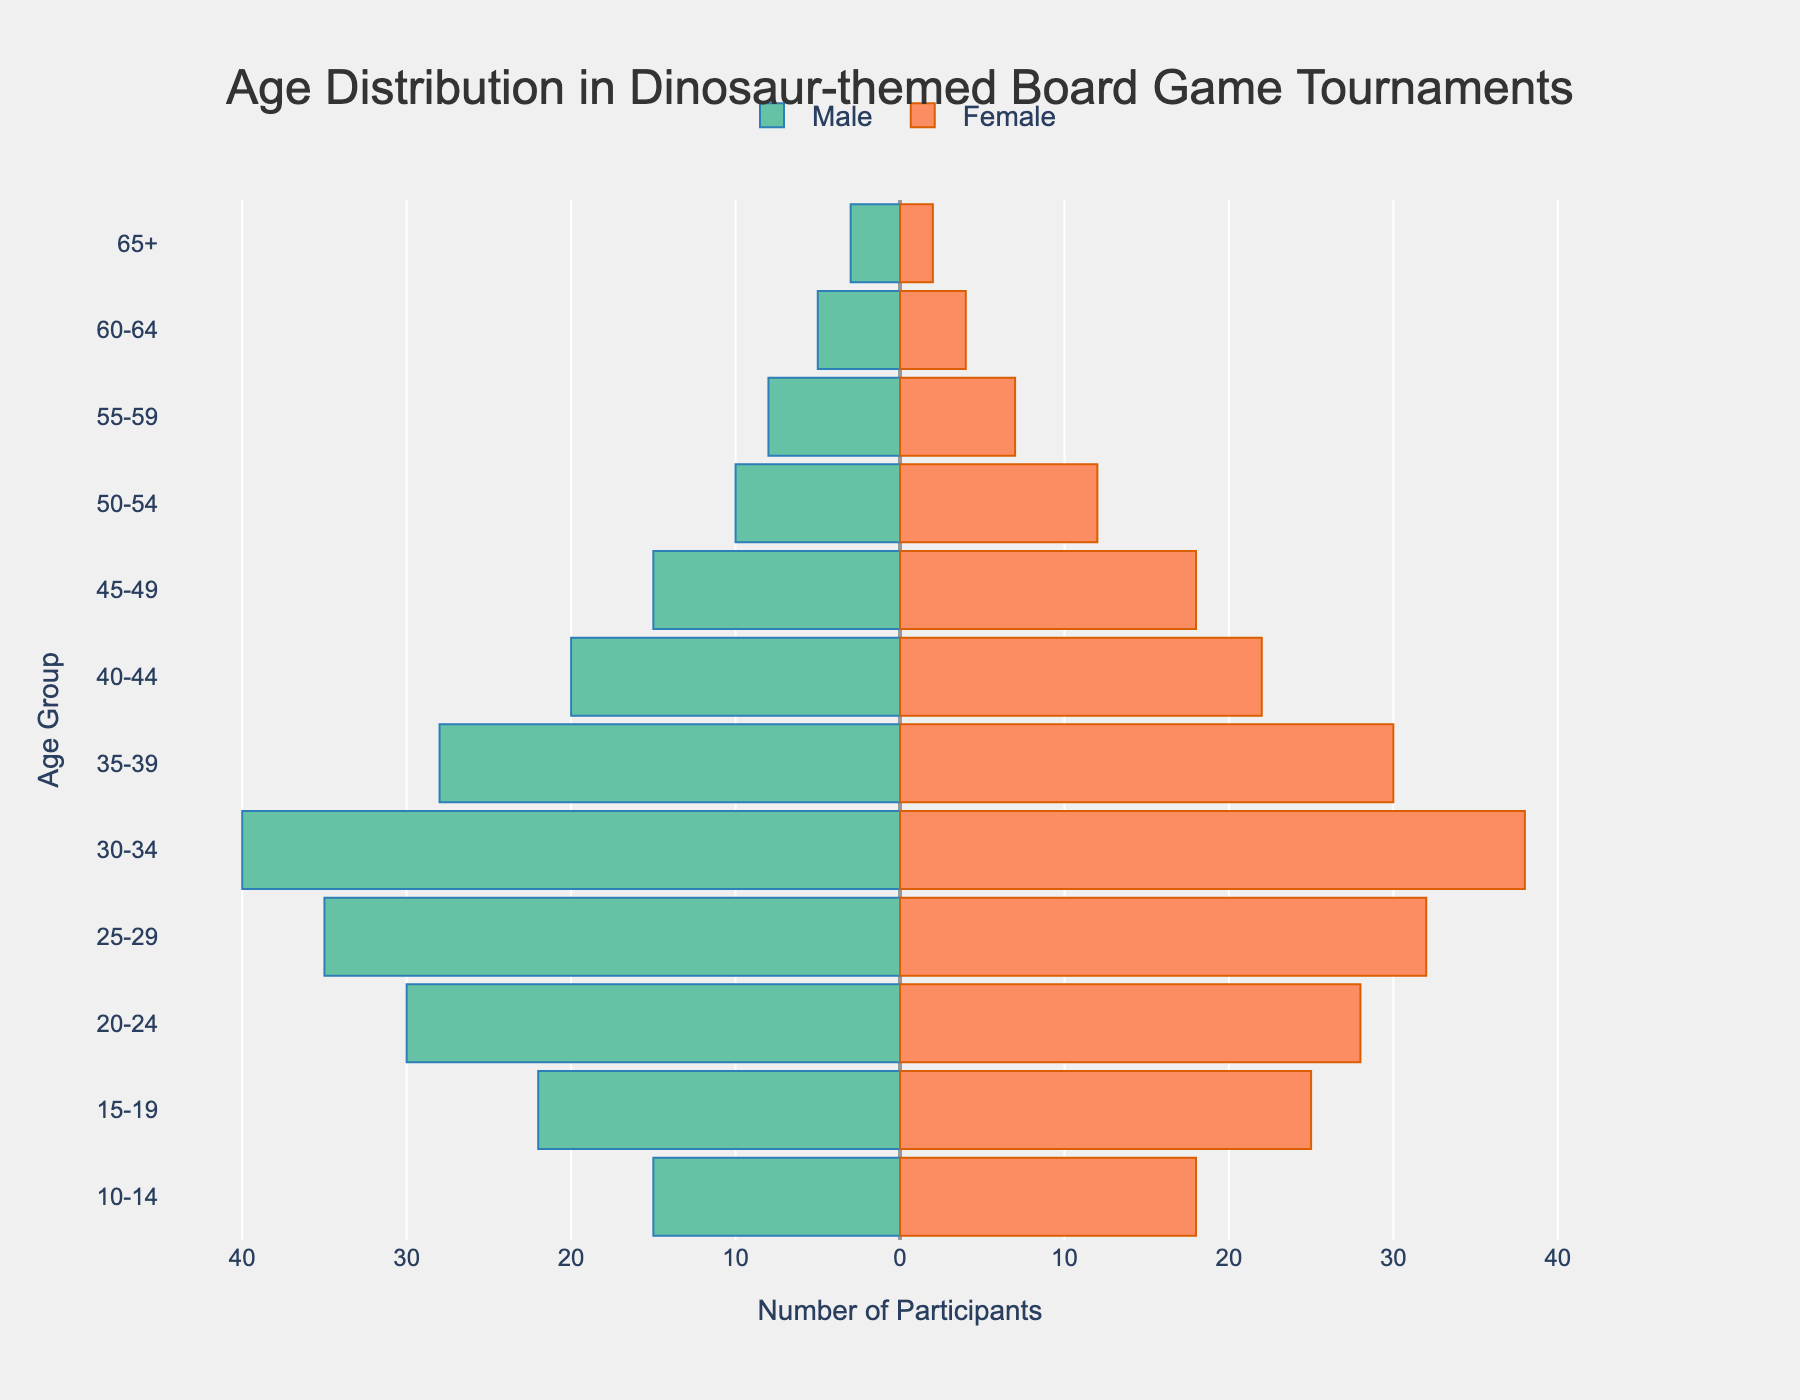what is the title of the figure? The title of the figure is placed at the top of the plot. It reads "Age Distribution in Dinosaur-themed Board Game Tournaments".
Answer: Age Distribution in Dinosaur-themed Board Game Tournaments what do the bars represent in the figure? The horizontal bars in the figure represent the number of participants within each age group, with different colors representing males and females.
Answer: number of participants within each age group how many females are in the 30-34 age group? To find the number of females in the 30-34 age group, look for the corresponding bar on the right side of the pyramid (in orange). The label indicates that there are 38 females in the 30-34 age group.
Answer: 38 what age group has the highest number of male participants? To determine the age group with the highest number of male participants, look for the longest bar on the left side of the pyramid (in green). The age group with the highest number is labeled in the 30-34 age group with 40 participants.
Answer: 30-34 what is the total number of participants in the 25-29 age group? To find the total number of participants in the 25-29 age group, add the number of males and females. There are 35 males and 32 females in this age group. So the total is 35 + 32 = 67.
Answer: 67 which gender has more participants in the 40-44 age group, and by how many? Compare the lengths of the bars for males and females in the 40-44 age group. Males have 20 participants, and females have 22. Females have 22 - 20 = 2 more participants than males.
Answer: females by 2 what is the range of age groups shown in the pyramid? The age groups shown in the pyramid range from the youngest to the oldest categories labeled on the y-axis. The age groups start from 10-14 and go up to 65+. Therefore, the range is from 10-14 to 65+.
Answer: 10-14 to 65+ how many participants are there in total in the 20-24 age group? To determine the total number of participants in the 20-24 age group, sum up the number of males and females. There are 30 males and 28 females, so the total is 30 + 28 = 58.
Answer: 58 what trend do you notice about the number of participants as age increases? Observing the figure from younger to older age groups, the general trend shows a decrease in the number of participants as age increases.
Answer: decreases as age increases 